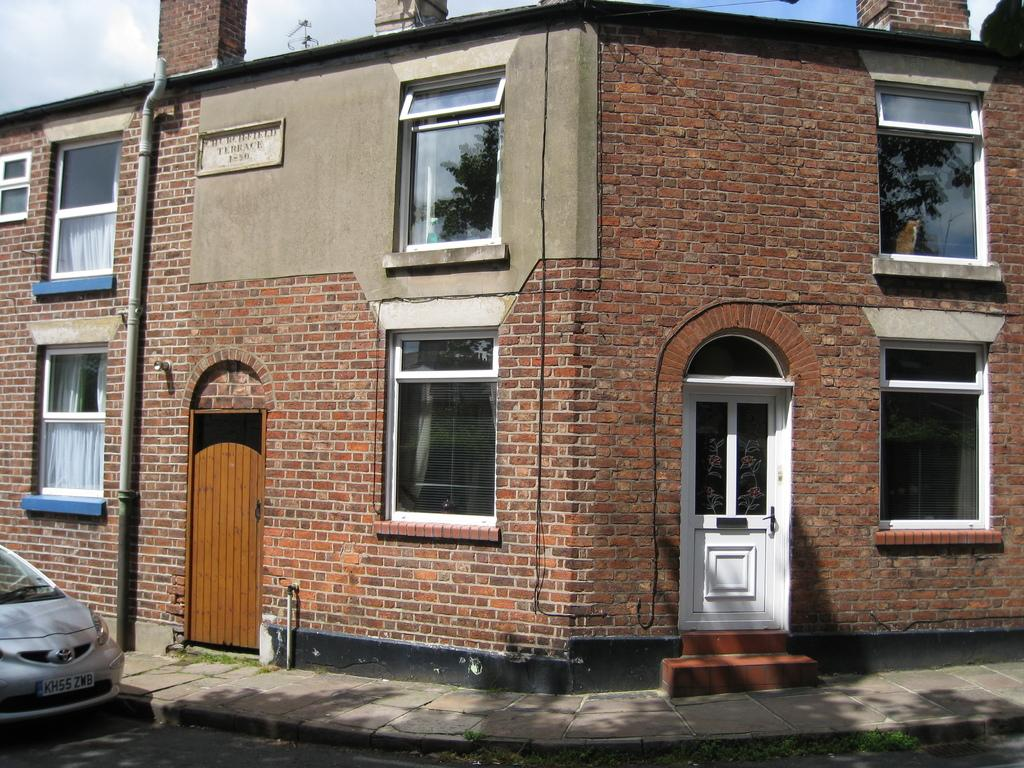What type of structure is visible in the image? There is a building in the image. What features can be seen on the building? There are doors and windows visible on the building. What object is present near the building? There is a board in the image. What other object can be seen in the image? There is a pipe in the image. What type of pathway is visible in the image? There is a road in the image. What is the condition of the vehicle in the image? The vehicle is truncated. What is visible at the top of the image? The sky is visible at the top of the image. What can be seen in the sky? There are clouds in the sky. What type of rake is being used to touch the clouds in the image? There is no rake or any indication of touching the clouds in the image. 